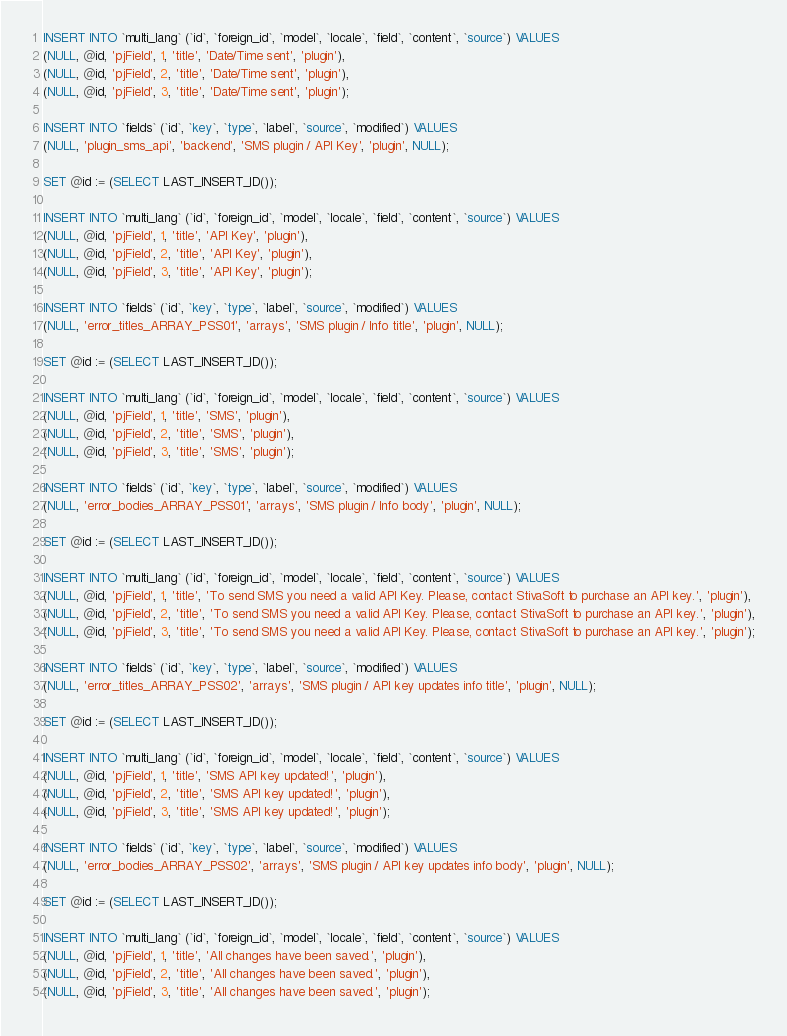Convert code to text. <code><loc_0><loc_0><loc_500><loc_500><_SQL_>
INSERT INTO `multi_lang` (`id`, `foreign_id`, `model`, `locale`, `field`, `content`, `source`) VALUES
(NULL, @id, 'pjField', 1, 'title', 'Date/Time sent', 'plugin'),
(NULL, @id, 'pjField', 2, 'title', 'Date/Time sent', 'plugin'),
(NULL, @id, 'pjField', 3, 'title', 'Date/Time sent', 'plugin');

INSERT INTO `fields` (`id`, `key`, `type`, `label`, `source`, `modified`) VALUES
(NULL, 'plugin_sms_api', 'backend', 'SMS plugin / API Key', 'plugin', NULL);

SET @id := (SELECT LAST_INSERT_ID());

INSERT INTO `multi_lang` (`id`, `foreign_id`, `model`, `locale`, `field`, `content`, `source`) VALUES
(NULL, @id, 'pjField', 1, 'title', 'API Key', 'plugin'),
(NULL, @id, 'pjField', 2, 'title', 'API Key', 'plugin'),
(NULL, @id, 'pjField', 3, 'title', 'API Key', 'plugin');

INSERT INTO `fields` (`id`, `key`, `type`, `label`, `source`, `modified`) VALUES
(NULL, 'error_titles_ARRAY_PSS01', 'arrays', 'SMS plugin / Info title', 'plugin', NULL);

SET @id := (SELECT LAST_INSERT_ID());

INSERT INTO `multi_lang` (`id`, `foreign_id`, `model`, `locale`, `field`, `content`, `source`) VALUES
(NULL, @id, 'pjField', 1, 'title', 'SMS', 'plugin'),
(NULL, @id, 'pjField', 2, 'title', 'SMS', 'plugin'),
(NULL, @id, 'pjField', 3, 'title', 'SMS', 'plugin');

INSERT INTO `fields` (`id`, `key`, `type`, `label`, `source`, `modified`) VALUES
(NULL, 'error_bodies_ARRAY_PSS01', 'arrays', 'SMS plugin / Info body', 'plugin', NULL);

SET @id := (SELECT LAST_INSERT_ID());

INSERT INTO `multi_lang` (`id`, `foreign_id`, `model`, `locale`, `field`, `content`, `source`) VALUES
(NULL, @id, 'pjField', 1, 'title', 'To send SMS you need a valid API Key. Please, contact StivaSoft to purchase an API key.', 'plugin'),
(NULL, @id, 'pjField', 2, 'title', 'To send SMS you need a valid API Key. Please, contact StivaSoft to purchase an API key.', 'plugin'),
(NULL, @id, 'pjField', 3, 'title', 'To send SMS you need a valid API Key. Please, contact StivaSoft to purchase an API key.', 'plugin');

INSERT INTO `fields` (`id`, `key`, `type`, `label`, `source`, `modified`) VALUES
(NULL, 'error_titles_ARRAY_PSS02', 'arrays', 'SMS plugin / API key updates info title', 'plugin', NULL);

SET @id := (SELECT LAST_INSERT_ID());

INSERT INTO `multi_lang` (`id`, `foreign_id`, `model`, `locale`, `field`, `content`, `source`) VALUES
(NULL, @id, 'pjField', 1, 'title', 'SMS API key updated!', 'plugin'),
(NULL, @id, 'pjField', 2, 'title', 'SMS API key updated!', 'plugin'),
(NULL, @id, 'pjField', 3, 'title', 'SMS API key updated!', 'plugin');

INSERT INTO `fields` (`id`, `key`, `type`, `label`, `source`, `modified`) VALUES
(NULL, 'error_bodies_ARRAY_PSS02', 'arrays', 'SMS plugin / API key updates info body', 'plugin', NULL);

SET @id := (SELECT LAST_INSERT_ID());

INSERT INTO `multi_lang` (`id`, `foreign_id`, `model`, `locale`, `field`, `content`, `source`) VALUES
(NULL, @id, 'pjField', 1, 'title', 'All changes have been saved.', 'plugin'),
(NULL, @id, 'pjField', 2, 'title', 'All changes have been saved.', 'plugin'),
(NULL, @id, 'pjField', 3, 'title', 'All changes have been saved.', 'plugin');</code> 